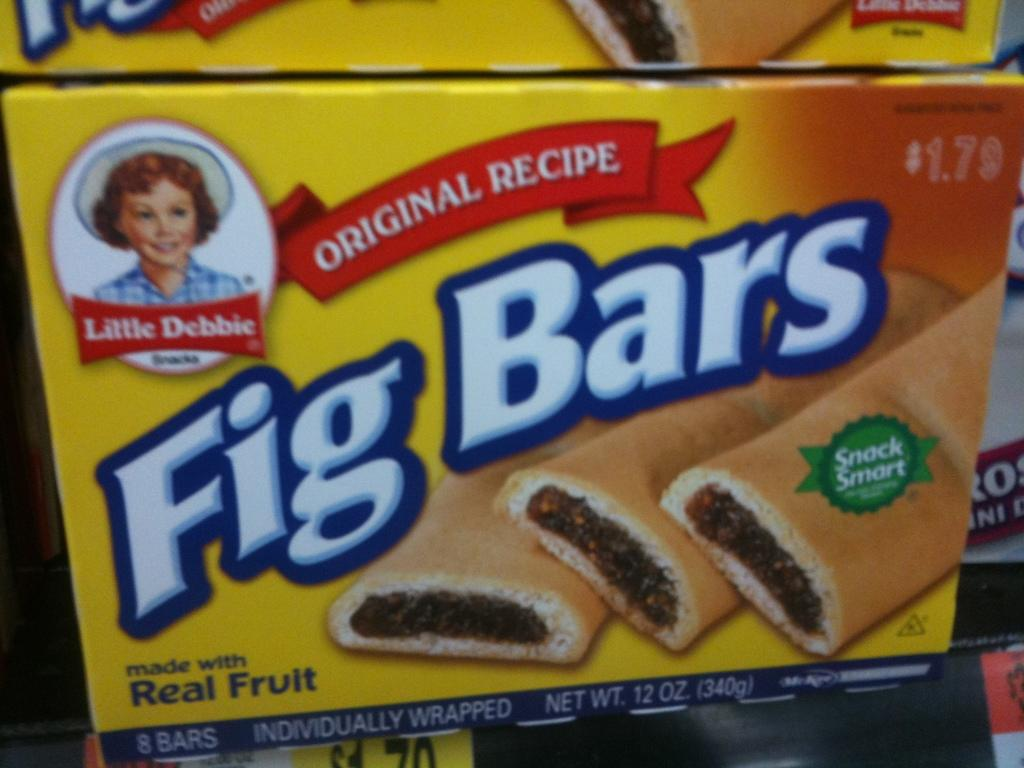What objects are present in the image? There are boxes in the image. What type of jam can be seen on the moon in the image? There is no jam or moon present in the image; it only features boxes. 